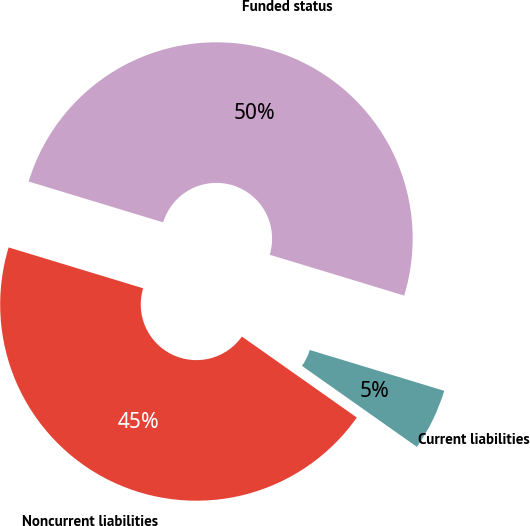Convert chart. <chart><loc_0><loc_0><loc_500><loc_500><pie_chart><fcel>Current liabilities<fcel>Noncurrent liabilities<fcel>Funded status<nl><fcel>5.08%<fcel>44.92%<fcel>50.0%<nl></chart> 